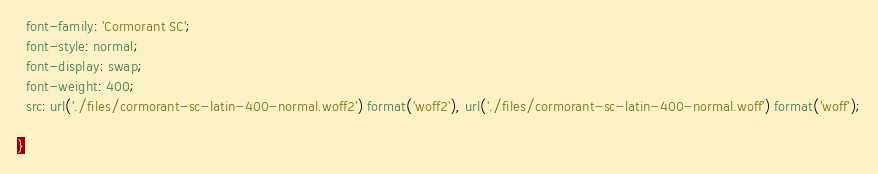<code> <loc_0><loc_0><loc_500><loc_500><_CSS_>  font-family: 'Cormorant SC';
  font-style: normal;
  font-display: swap;
  font-weight: 400;
  src: url('./files/cormorant-sc-latin-400-normal.woff2') format('woff2'), url('./files/cormorant-sc-latin-400-normal.woff') format('woff');
  
}
</code> 